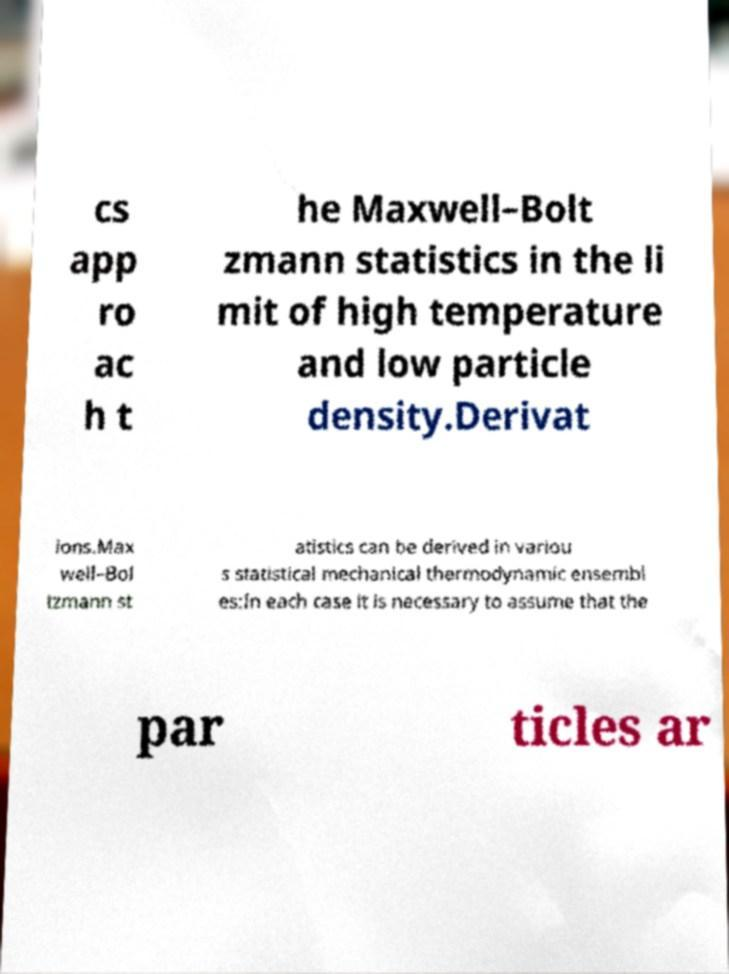Can you accurately transcribe the text from the provided image for me? cs app ro ac h t he Maxwell–Bolt zmann statistics in the li mit of high temperature and low particle density.Derivat ions.Max well–Bol tzmann st atistics can be derived in variou s statistical mechanical thermodynamic ensembl es:In each case it is necessary to assume that the par ticles ar 